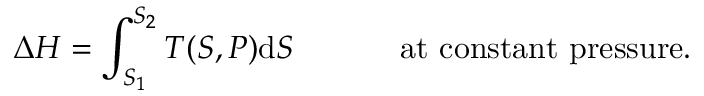Convert formula to latex. <formula><loc_0><loc_0><loc_500><loc_500>\Delta H = \int _ { S _ { 1 } } ^ { S _ { 2 } } T ( S , P ) d S \, { a t c o n s t a n t p r e s s u r e . }</formula> 